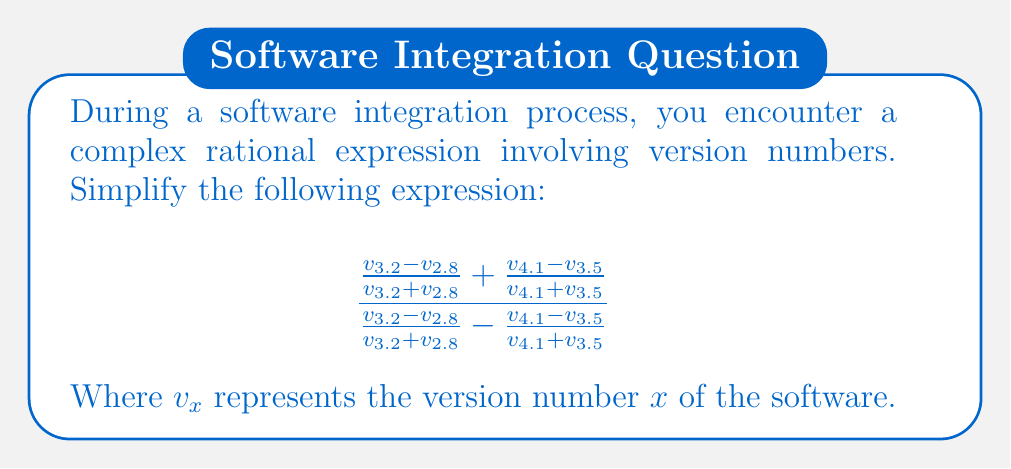What is the answer to this math problem? Let's simplify this complex rational expression step by step:

1) First, let's substitute simpler variables for each fraction:
   Let $a = \frac{v_{3.2} - v_{2.8}}{v_{3.2} + v_{2.8}}$ and $b = \frac{v_{4.1} - v_{3.5}}{v_{4.1} + v_{3.5}}$

2) Now our expression becomes:
   $$\frac{a + b}{a - b}$$

3) To simplify this, we can use the formula for the quotient of the sum and difference of two terms:
   $$\frac{x + y}{x - y} = \frac{(x + y)^2}{(x + y)(x - y)} = \frac{x + y}{x - y} \cdot \frac{x + y}{x + y} = \frac{(x + y)^2}{x^2 - y^2}$$

4) Applying this to our expression:
   $$\frac{a + b}{a - b} = \frac{(a + b)^2}{a^2 - b^2}$$

5) Expanding the numerator:
   $$\frac{a^2 + 2ab + b^2}{a^2 - b^2}$$

6) The $a^2$ terms cancel out:
   $$\frac{2ab + b^2}{-b^2} = -\frac{2ab + b^2}{b^2}$$

7) Factor out $b^2$ from the numerator:
   $$-\frac{b^2(2\frac{a}{b} + 1)}{b^2} = -(2\frac{a}{b} + 1)$$

8) Substituting back the original fractions:
   $$-(2\frac{\frac{v_{3.2} - v_{2.8}}{v_{3.2} + v_{2.8}}}{\frac{v_{4.1} - v_{3.5}}{v_{4.1} + v_{3.5}}} + 1)$$

This is the simplified form of the complex rational expression.
Answer: $-(2\frac{\frac{v_{3.2} - v_{2.8}}{v_{3.2} + v_{2.8}}}{\frac{v_{4.1} - v_{3.5}}{v_{4.1} + v_{3.5}}} + 1)$ 